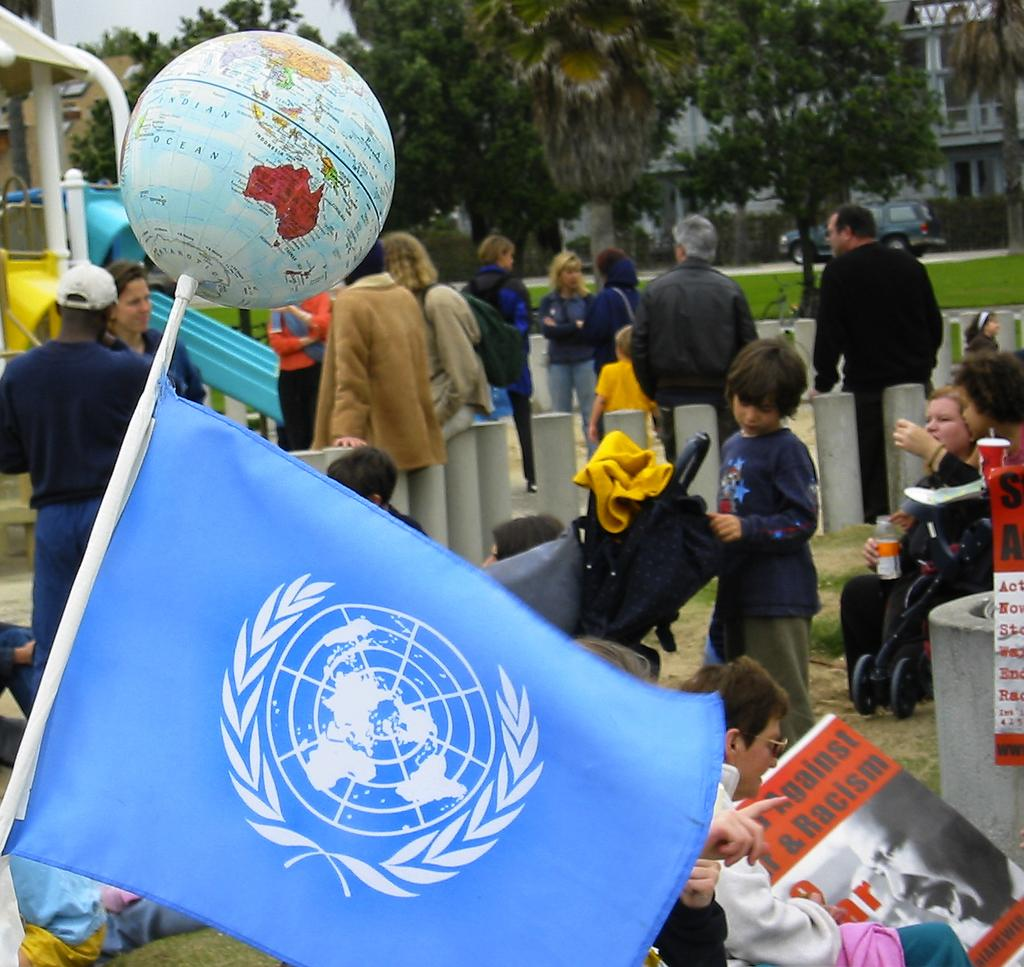What is the main object in the image? There is a globe in the image. What else can be seen in the image besides the globe? There is a flag on a stick, people, trees, grass, a car, a building, and the sky visible in the background of the image. What type of wall can be seen in the image? There is no wall present in the image. Can you hear the people in the image laughing? The image is a still picture, so there is no sound or laughter present. 